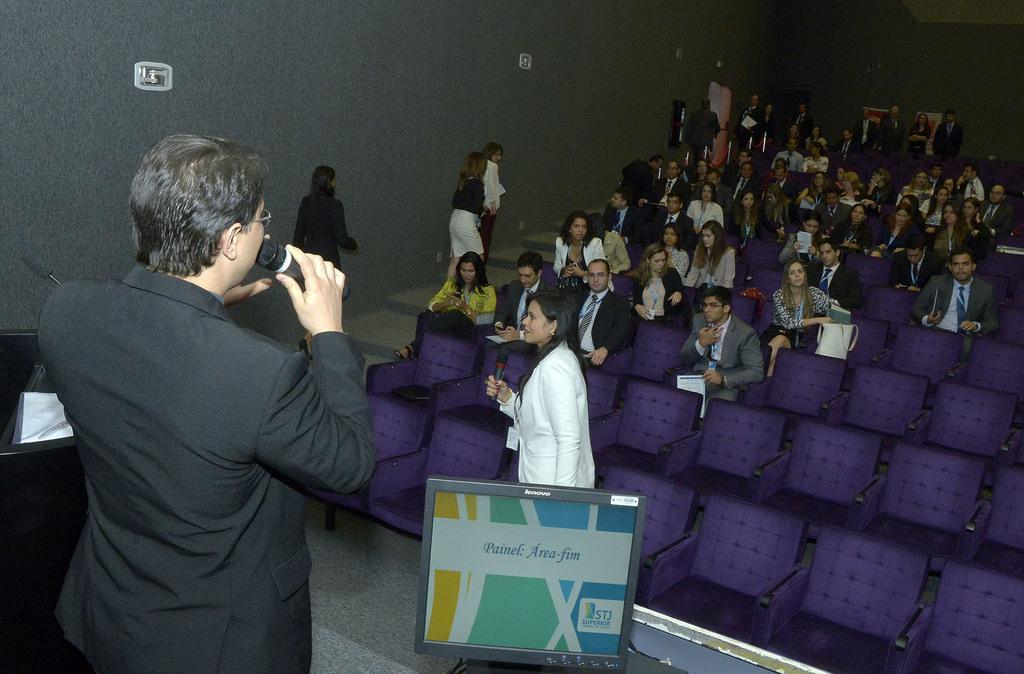Can you describe this image briefly? In this picture I can observe some people sitting in the chairs in an auditorium. There are men and women in this picture. On the left side there is a person standing, wearing a coat and holding a mic in his hand. In the background there is a wall. 